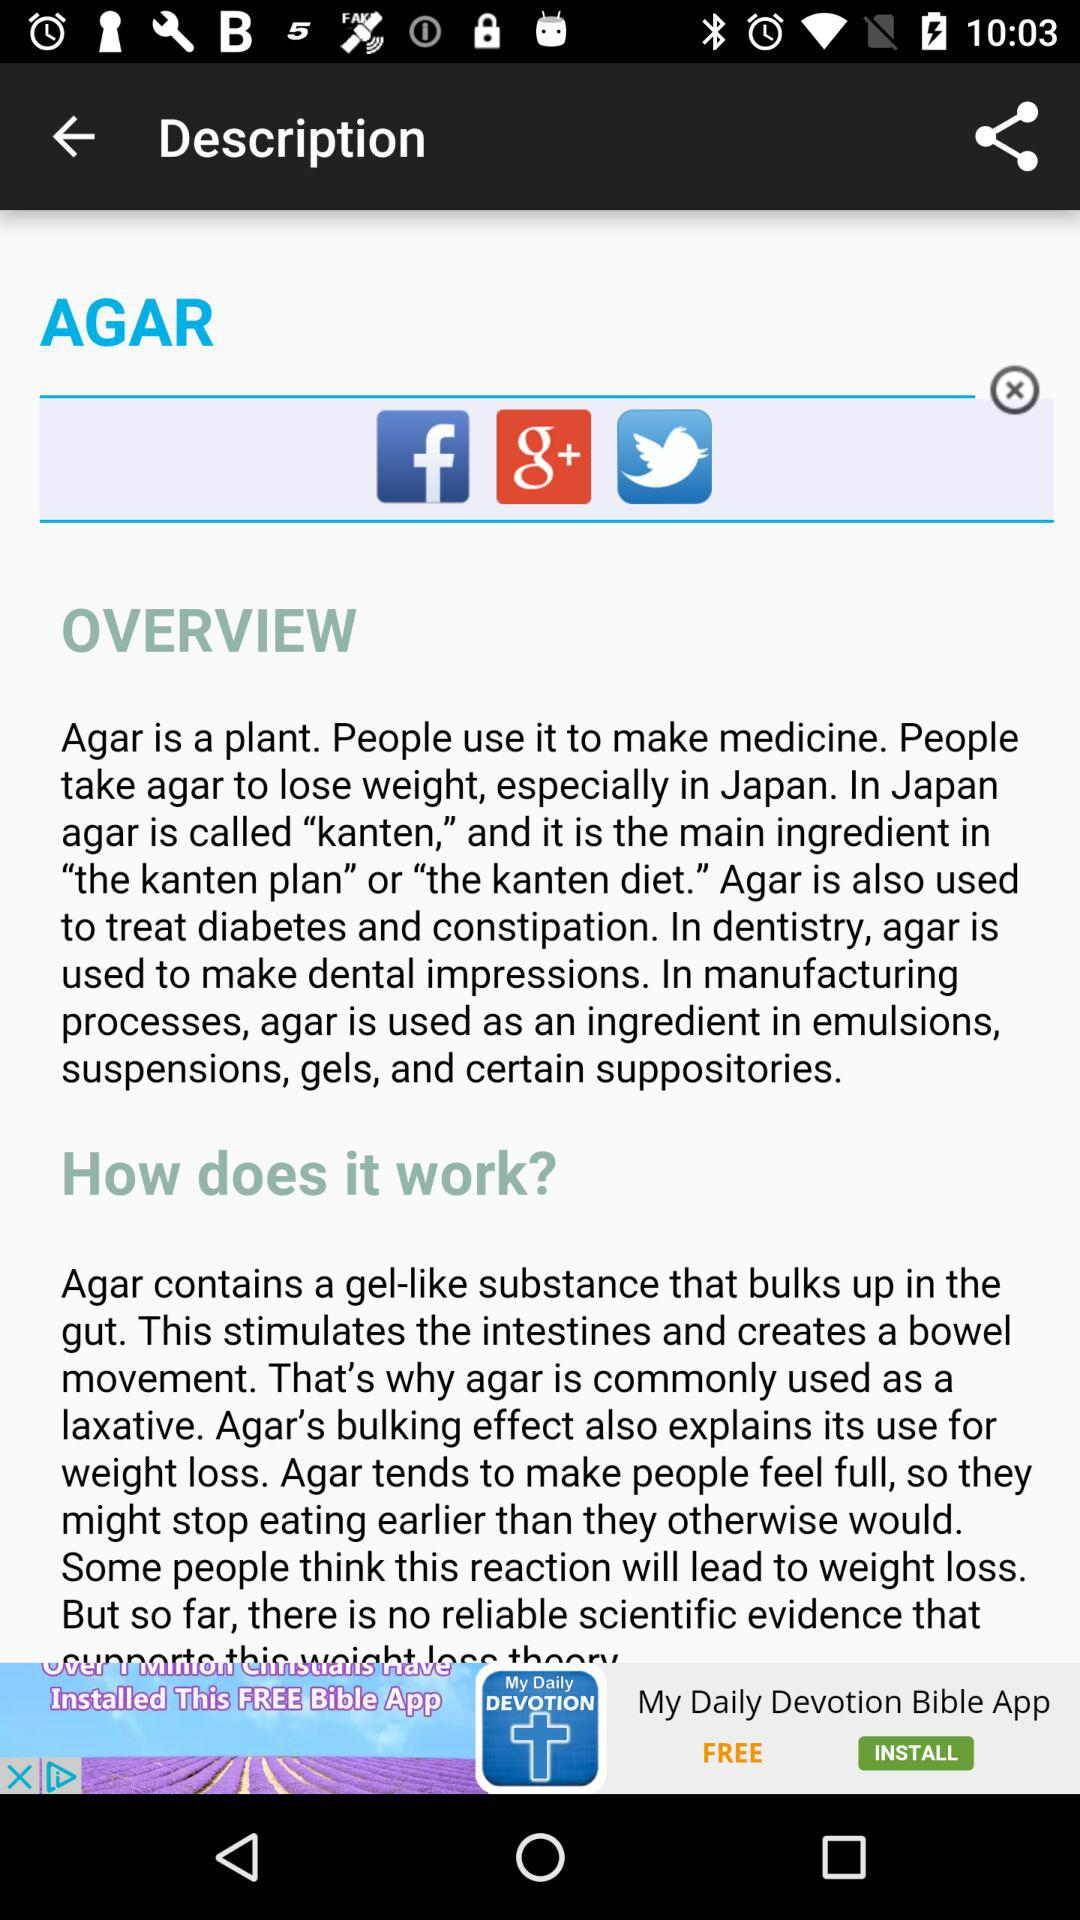How is agar commonly used? Agar is commonly used as a laxative. 